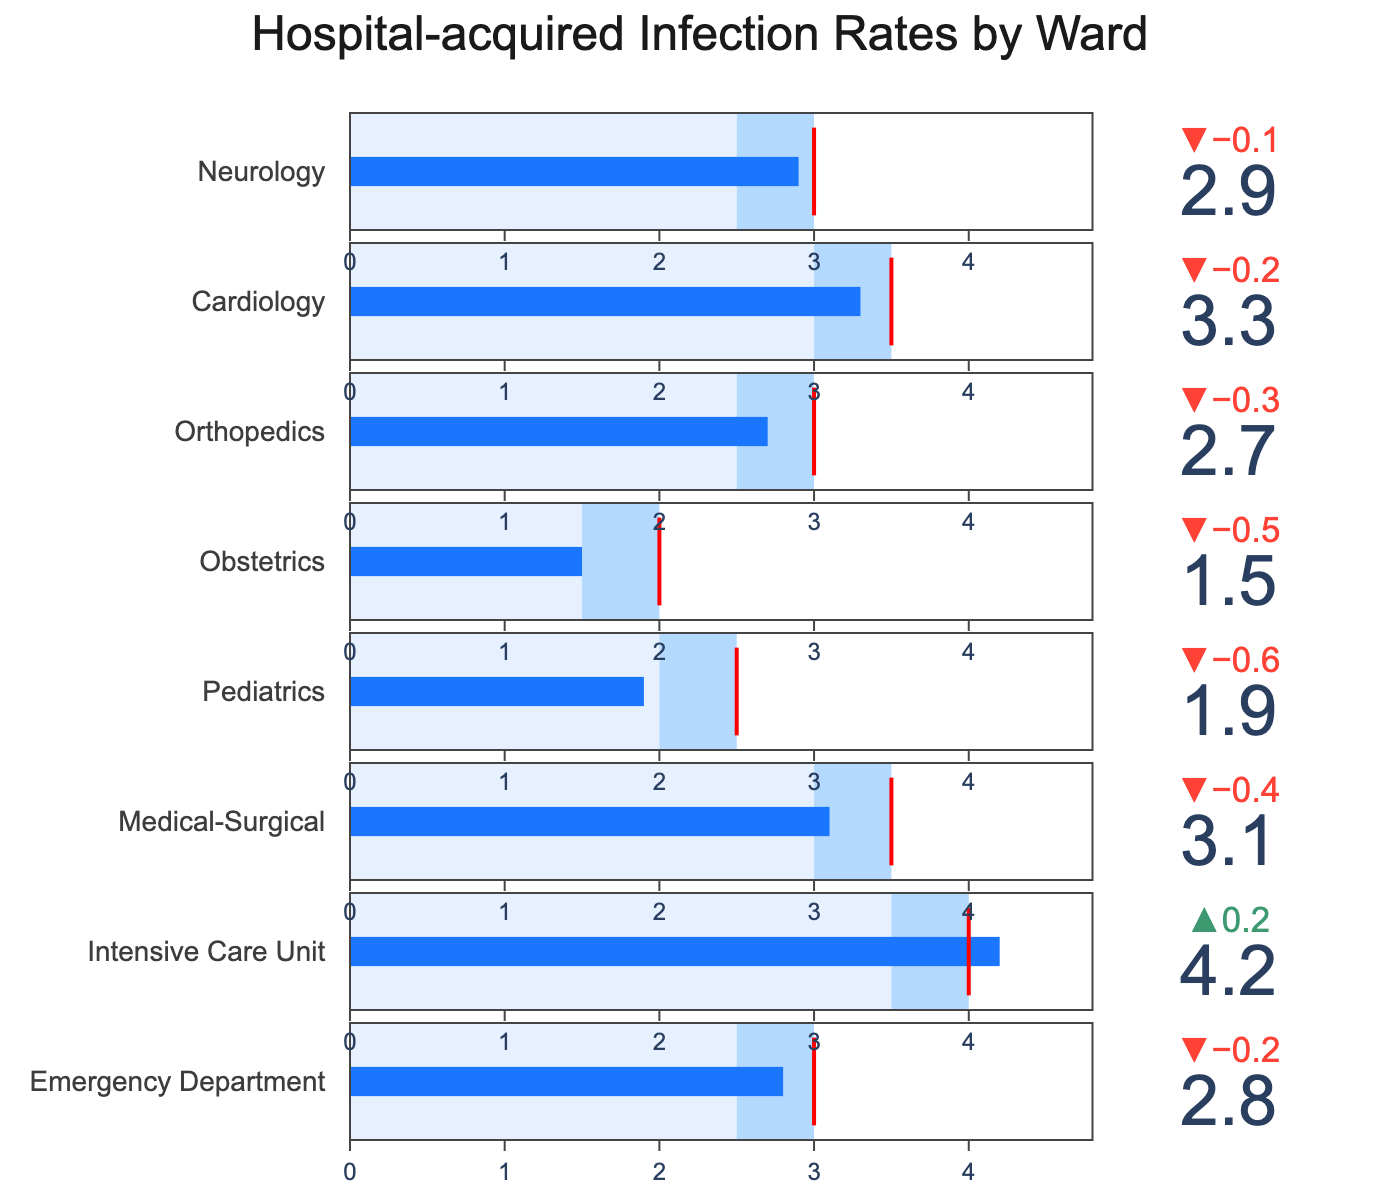How many wards are displayed in the figure? Count the total number of distinct wards listed in the figure.
Answer: 8 What is the title of the chart? The title is normally displayed at the top of the chart; read the text presented there.
Answer: Hospital-acquired Infection Rates by Ward Which ward has the highest infection rate? Find the ward with the maximum value shown for the infection rate.
Answer: Intensive Care Unit Which ward's infection rate is equal to its target? Check for the ward where the infection rate value is exactly the same as the target value.
Answer: Obstetrics How many wards have infection rates below the national standard? Compare the infection rates of all wards with their respective national standards and count those below.
Answer: 4 In which ward is the infection rate most significantly lower than the national standard? Subtract the infection rates from the national standards and identify the ward with the highest difference in favor of the infection rate.
Answer: Pediatrics What's the average infection rate across all wards? Sum the infection rates of all wards and then divide by the number of wards. [(2.8 + 4.2 + 3.1 + 1.9 + 1.5 + 2.7 + 3.3 + 2.9) / 8]
Answer: 2.8 What's the difference between the infection rate in Neurology and the national standard for the same ward? Subtract the Neurology infection rate from its national standard: 3.0 - 2.9
Answer: 0.1 Which wards have an infection rate that meets or exceeds the national standard? Compare each ward's infection rate to its national standard and identify those meeting or exceeding the standard.
Answer: Intensive Care Unit, Cardiology How does the infection rate of the Emergency Department compare to the target for that ward? Compare the infection rate of the Emergency Department to its target value.
Answer: 0.3 higher 